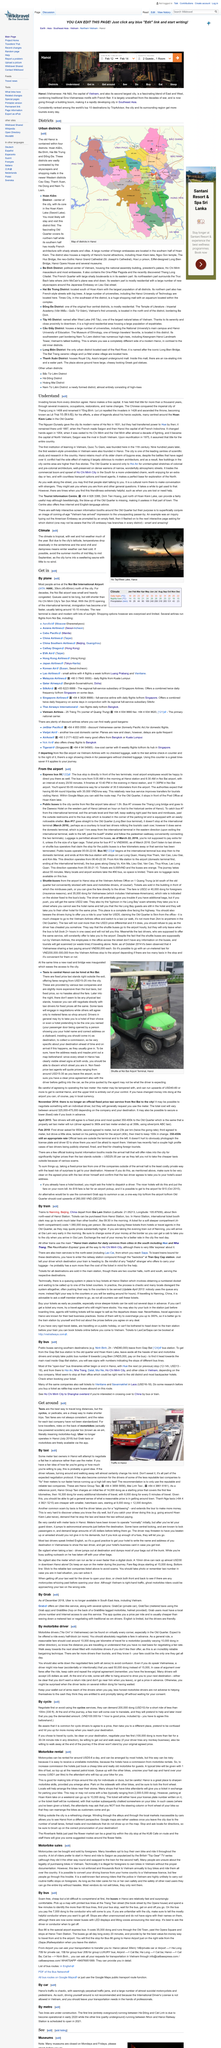Indicate a few pertinent items in this graphic. The political center of Vietnam is Ba Dinh District, as declared by the government. Yes, Ha Dong District is one of the other urban districts in Hanoi. The top right picture was taken in Hanoi. The map demonstrates the districts in Hanoi. I would arrive at Noi Bai International Airport if I were to travel by plane. 